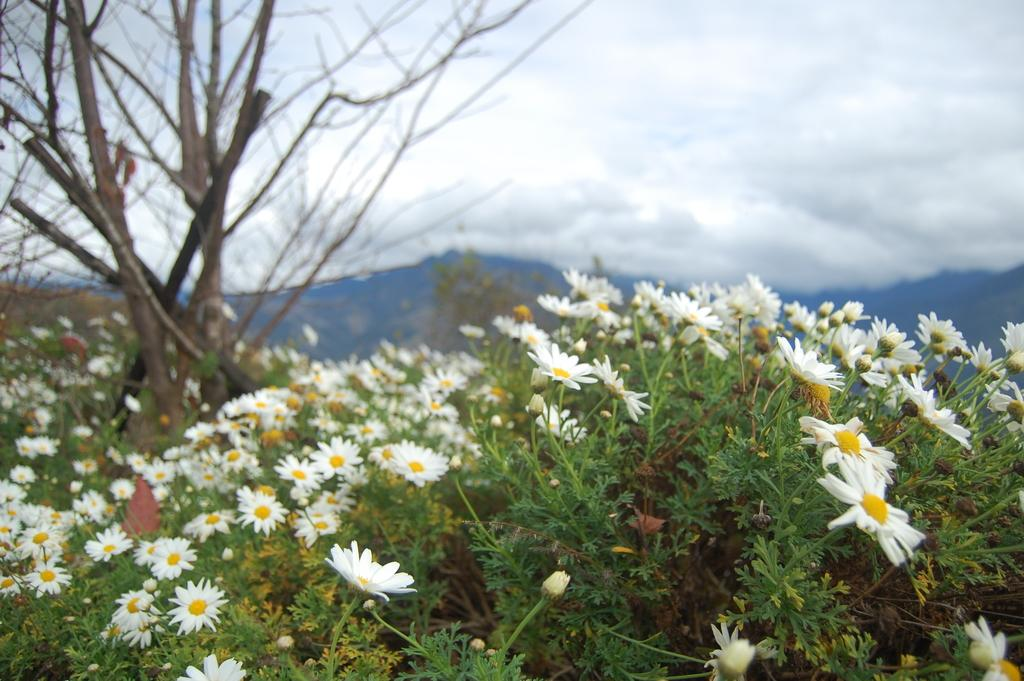What type of natural formation can be seen in the image? There are mountains in the image. What is the condition of the trees in the image? The trees in the image are dry. What type of flowers are present in the image? There are white and yellow color flowers in the image. How would you describe the color of the sky in the image? The sky is a combination of white and blue colors. Can you see a carriage being pulled by horses in the image? There is no carriage or horses present in the image. Is there a cave visible in the image? There is no cave visible in the image. 